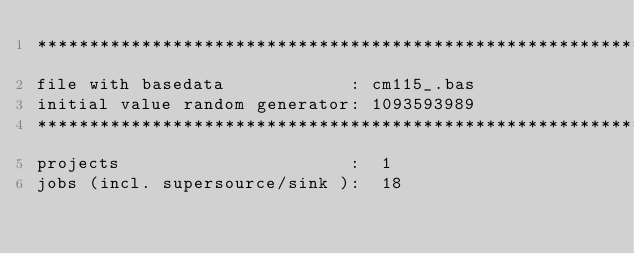<code> <loc_0><loc_0><loc_500><loc_500><_ObjectiveC_>************************************************************************
file with basedata            : cm115_.bas
initial value random generator: 1093593989
************************************************************************
projects                      :  1
jobs (incl. supersource/sink ):  18</code> 